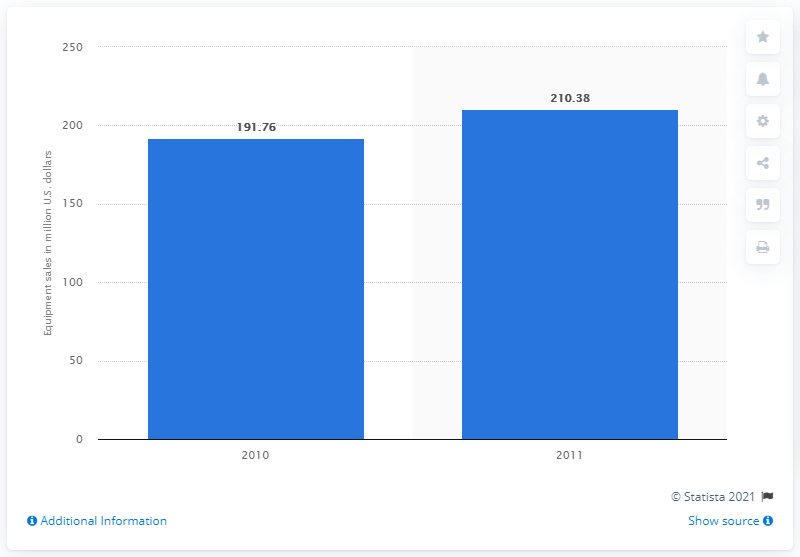Point out several critical features in this image. The total sales of sleeping bags in the United States in 2010 were 191.76 units. 